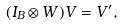Convert formula to latex. <formula><loc_0><loc_0><loc_500><loc_500>( I _ { B } \otimes W ) V = V ^ { \prime } ,</formula> 